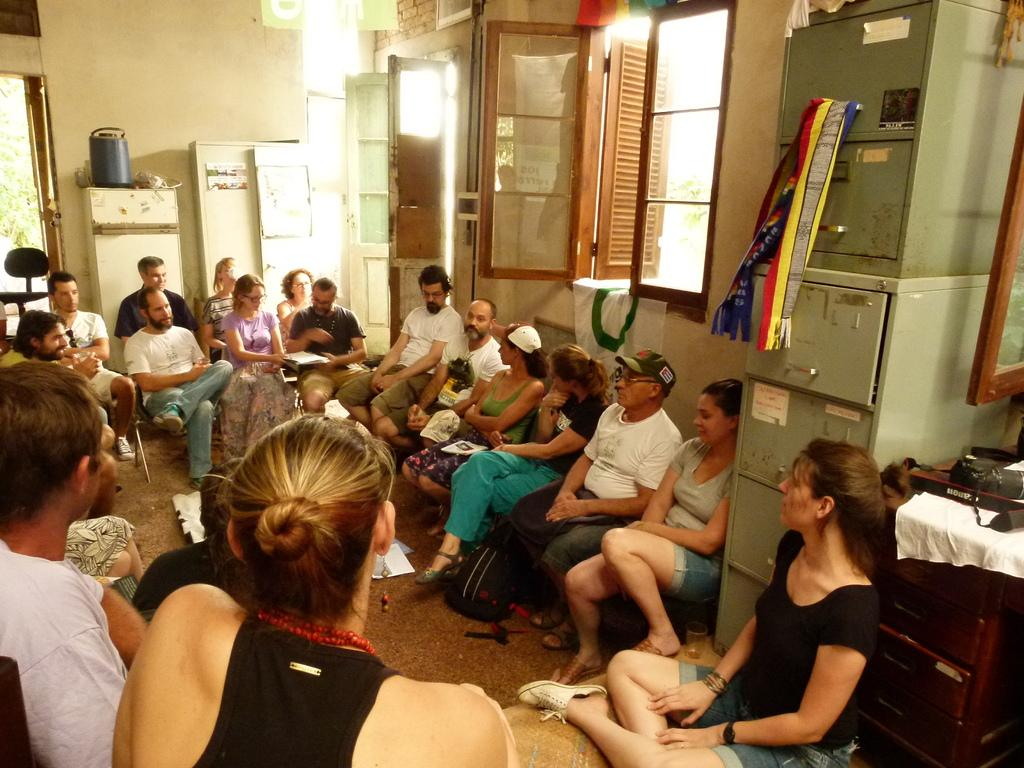How many people are in the room in the image? There is a group of people in the room. What can be found on the right side of the room? There is an iron drawer on the right side of the room. What are some features of the room that allow for movement or access? There are doors and windows in the room. What type of substance is being poured from the sink in the image? There is no sink present in the image, so it is not possible to answer that question. 